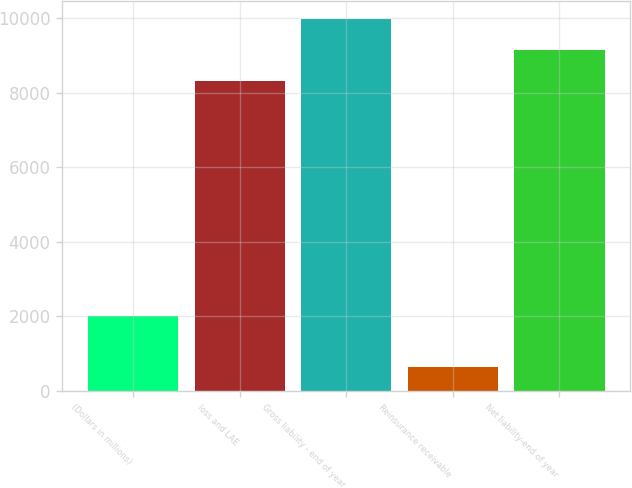Convert chart to OTSL. <chart><loc_0><loc_0><loc_500><loc_500><bar_chart><fcel>(Dollars in millions)<fcel>loss and LAE<fcel>Gross liability - end of year<fcel>Reinsurance receivable<fcel>Net liability-end of year<nl><fcel>2009<fcel>8315.9<fcel>9979.08<fcel>641.5<fcel>9147.49<nl></chart> 